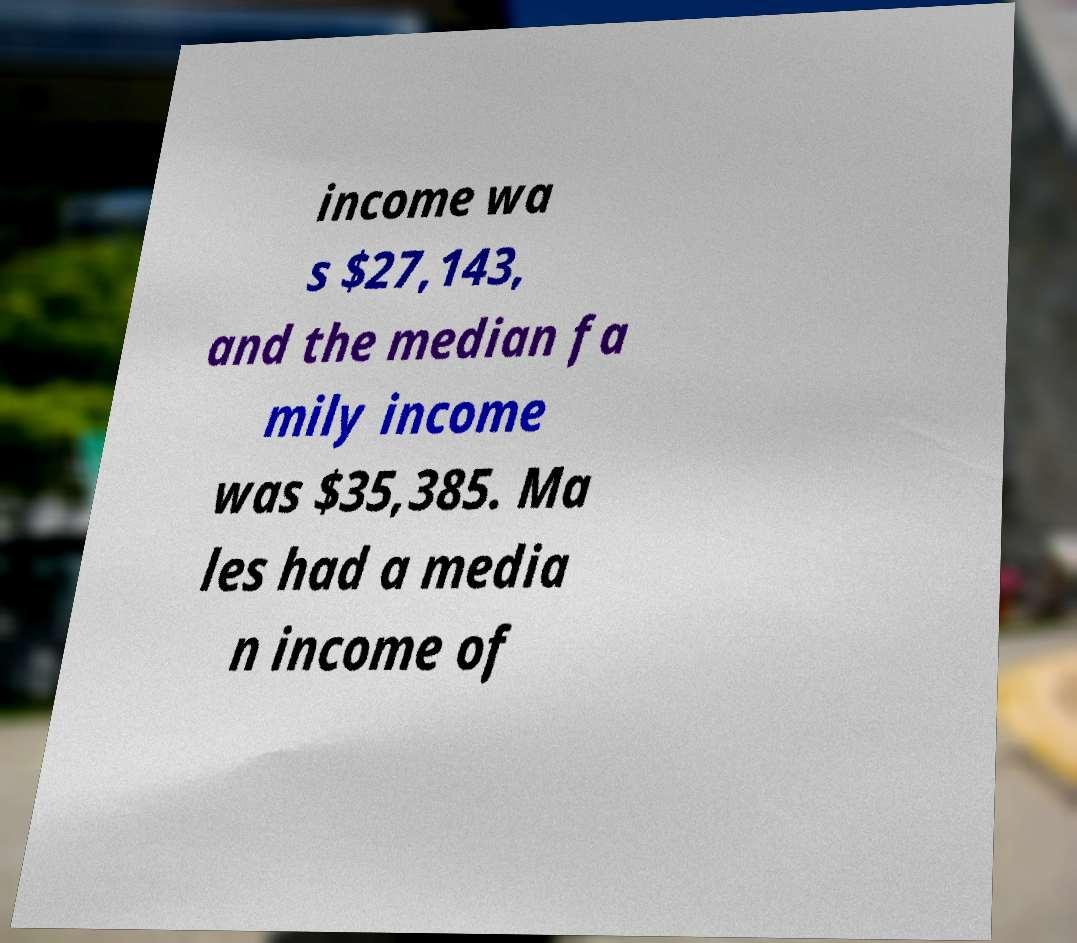Could you extract and type out the text from this image? income wa s $27,143, and the median fa mily income was $35,385. Ma les had a media n income of 